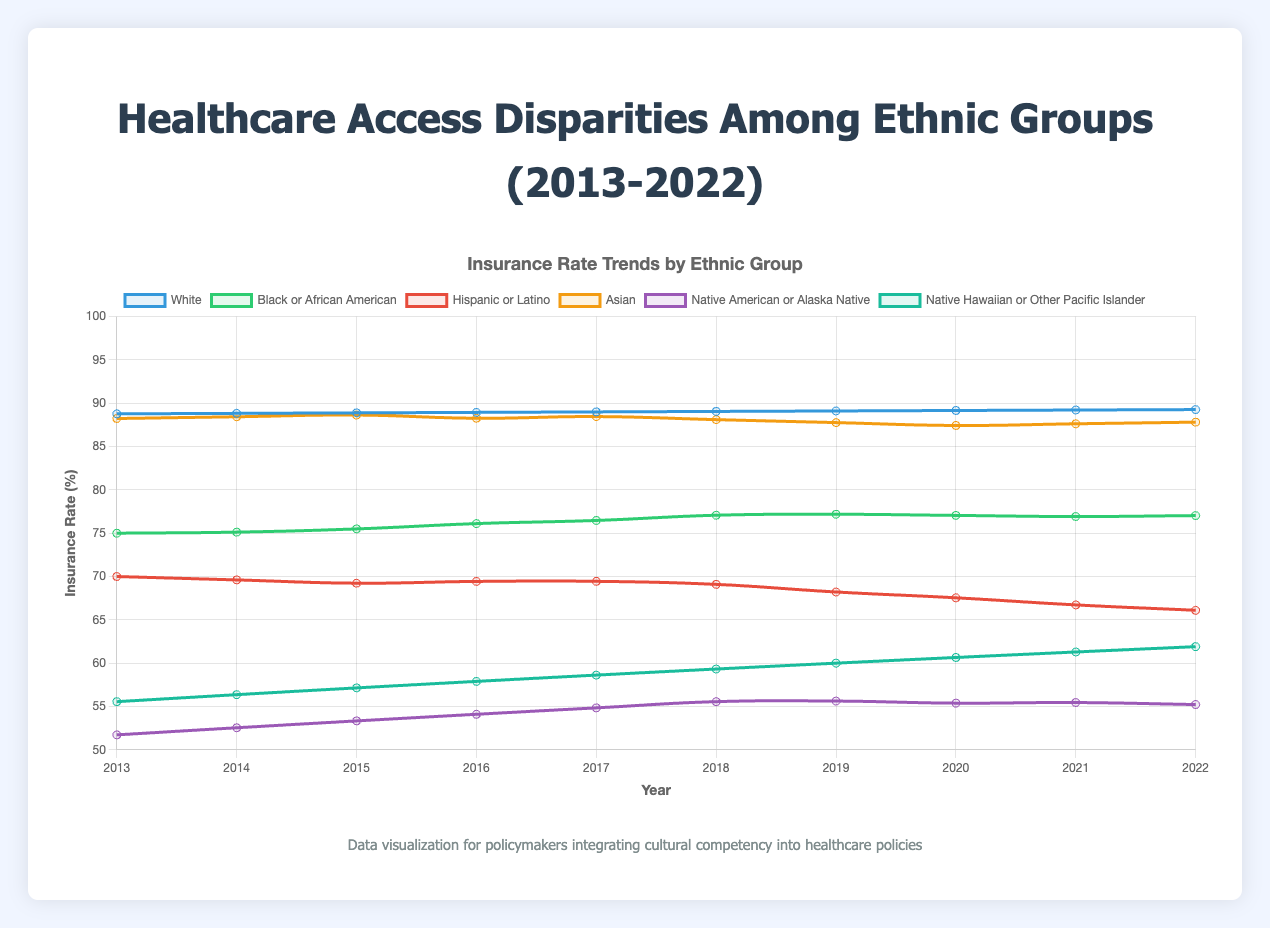What is the insurance rate for the White ethnic group in 2022? Look at the end of the line corresponding to the White ethnic group (blue line) on the plot and find its value for 2022.
Answer: 89.3% How does the insurance rate of Hispanic or Latino group in 2016 compare to Black or African American group in the same year? Identify the data points for the Hispanic or Latino group (red line) and the Black or African American group (green line) in 2016. Compare their values.
Answer: Hispanic or Latino: 69.4%, Black or African American: 76.1% Which ethnic group showed the greatest increase in insurance rate from 2013 to 2022? Calculate the difference in insurance rates from 2013 to 2022 for each ethnic group by taking the value in 2022 and subtracting the value in 2013. Identify the group with the maximum increase.
Answer: Native Hawaiian or Other Pacific Islander What is the average insurance rate for the Asian group over the entire decade? Sum the insurance rates for the Asian group (yellow line) for each year from 2013 to 2022, then divide by the number of years.
Answer: (88.2% + 88.4% + 88.6% + 88.3% + 88.5% + 88.1% + 87.8% + 87.4% + 87.6% + 87.8%) / 10 ≈ 87.97% Is there any year where the insurance rate for Native American or Alaska Native group is greater than 60%? Check the data points along the purple line corresponding to the Native American or Alaska Native group to see if any values exceed 60%.
Answer: No Compare the trend lines for the insurance rates of Asian and White groups from 2013 to 2022. Which group had a consistently higher rate? Examine the trends of the yellow line (Asian) and blue line (White) from 2013 to 2022. Identify which line is higher at each point.
Answer: Asian group Which year had the smallest disparity in insurance rates between the Asian group and the Hispanic or Latino group? For each year, calculate the absolute difference between the insurance rates of the Asian group (yellow line) and the Hispanic or Latino group (red line). Identify the year with the minimum difference.
Answer: 2021 What was the approximate insurance rate increase for the Black or African American group from 2014 to 2017? Subtract the insurance rate in 2014 from the rate in 2017 for the Black or African American group (green line).
Answer: 77.8% - 75.1% = 2.7% In 2020, how did the insurance rate of Native Hawaiian or Other Pacific Islander compare to Native American or Alaska Native? Identify the data points for 2020 for the Native Hawaiian or Other Pacific Islander (turquoise line) and Native American or Alaska Native (purple line). Compare their values.
Answer: Native Hawaiian or Other Pacific Islander: 60.7%, Native American or Alaska Native: 55.4% By looking at the trend, which ethnic group had the most stable insurance rates over the decade? Identify the group with the least fluctuation in its trend line across the years, appearing the most flat.
Answer: Asian group 